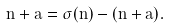<formula> <loc_0><loc_0><loc_500><loc_500>n + a = \sigma ( n ) - ( n + a ) .</formula> 